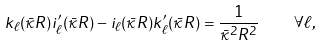<formula> <loc_0><loc_0><loc_500><loc_500>k _ { \ell } ( \bar { \kappa } R ) i _ { \ell } ^ { \prime } ( \bar { \kappa } R ) - i _ { \ell } ( \bar { \kappa } R ) k _ { \ell } ^ { \prime } ( \bar { \kappa } R ) = \frac { 1 } { \bar { \kappa } ^ { 2 } R ^ { 2 } } \quad \forall \ell ,</formula> 